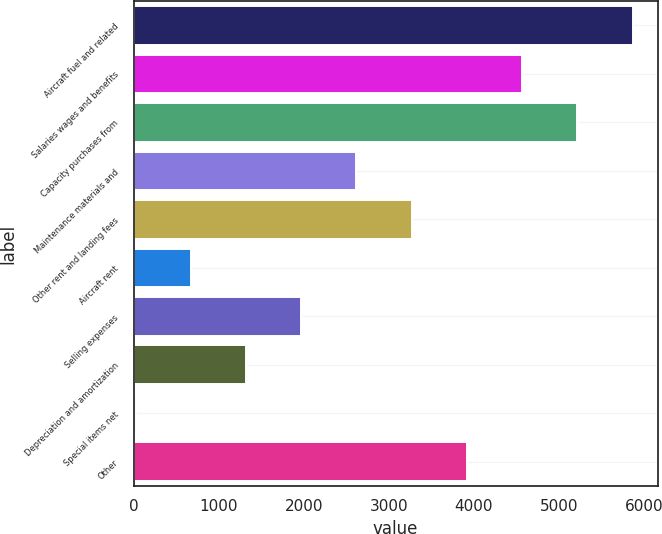Convert chart to OTSL. <chart><loc_0><loc_0><loc_500><loc_500><bar_chart><fcel>Aircraft fuel and related<fcel>Salaries wages and benefits<fcel>Capacity purchases from<fcel>Maintenance materials and<fcel>Other rent and landing fees<fcel>Aircraft rent<fcel>Selling expenses<fcel>Depreciation and amortization<fcel>Special items net<fcel>Other<nl><fcel>5866.8<fcel>4568.4<fcel>5217.6<fcel>2620.8<fcel>3270<fcel>673.2<fcel>1971.6<fcel>1322.4<fcel>24<fcel>3919.2<nl></chart> 